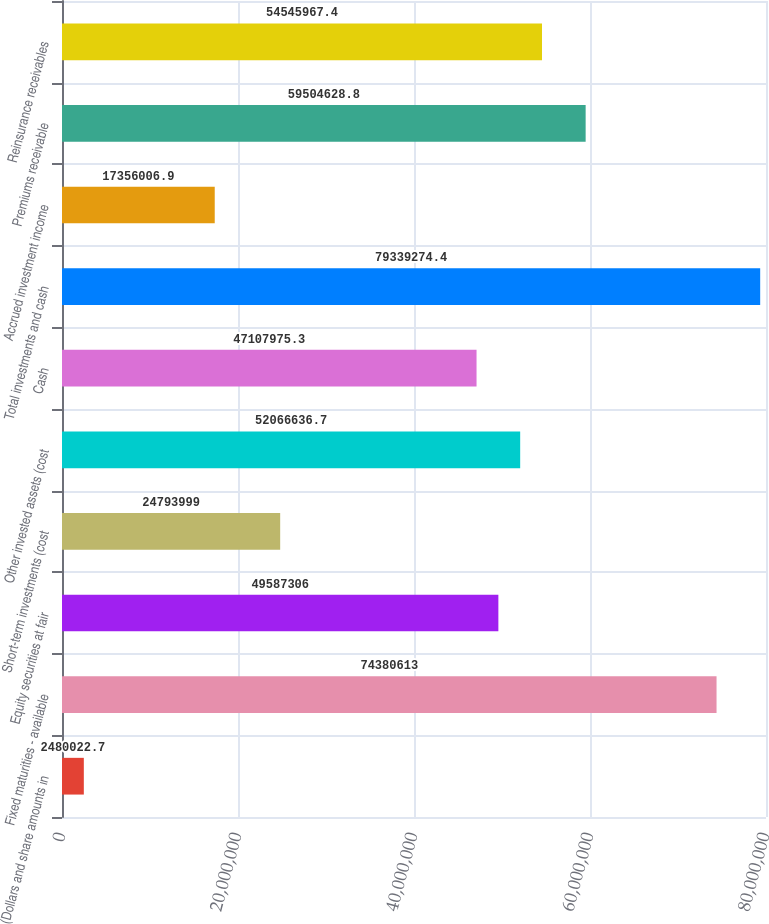<chart> <loc_0><loc_0><loc_500><loc_500><bar_chart><fcel>(Dollars and share amounts in<fcel>Fixed maturities - available<fcel>Equity securities at fair<fcel>Short-term investments (cost<fcel>Other invested assets (cost<fcel>Cash<fcel>Total investments and cash<fcel>Accrued investment income<fcel>Premiums receivable<fcel>Reinsurance receivables<nl><fcel>2.48002e+06<fcel>7.43806e+07<fcel>4.95873e+07<fcel>2.4794e+07<fcel>5.20666e+07<fcel>4.7108e+07<fcel>7.93393e+07<fcel>1.7356e+07<fcel>5.95046e+07<fcel>5.4546e+07<nl></chart> 